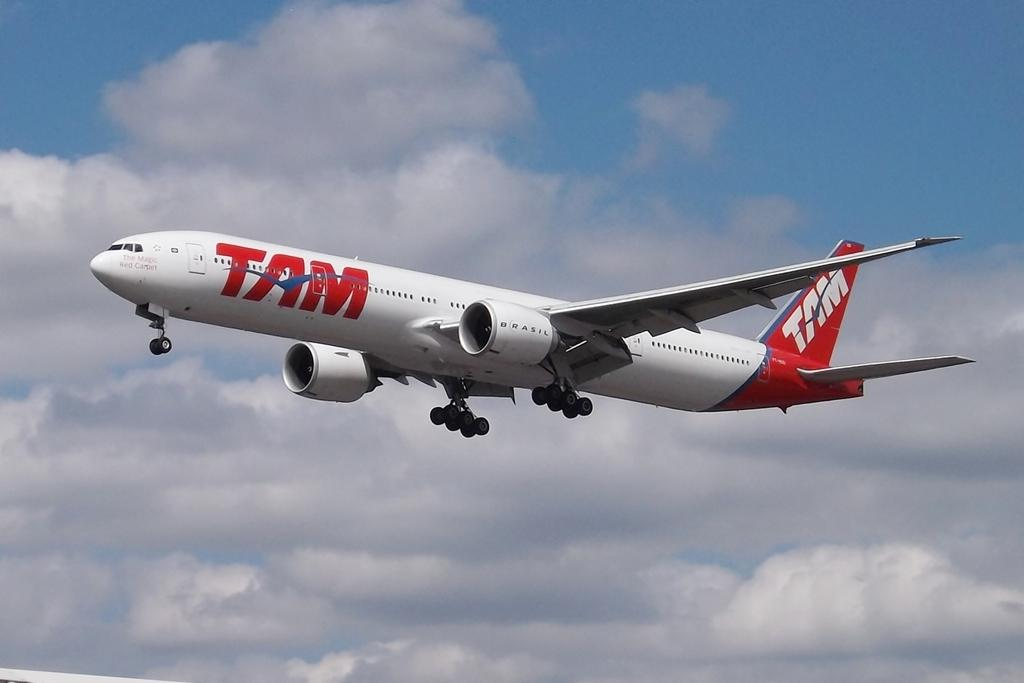<image>
Summarize the visual content of the image. An airplane with TAM painted on the side and tailfin flies through the sky. 